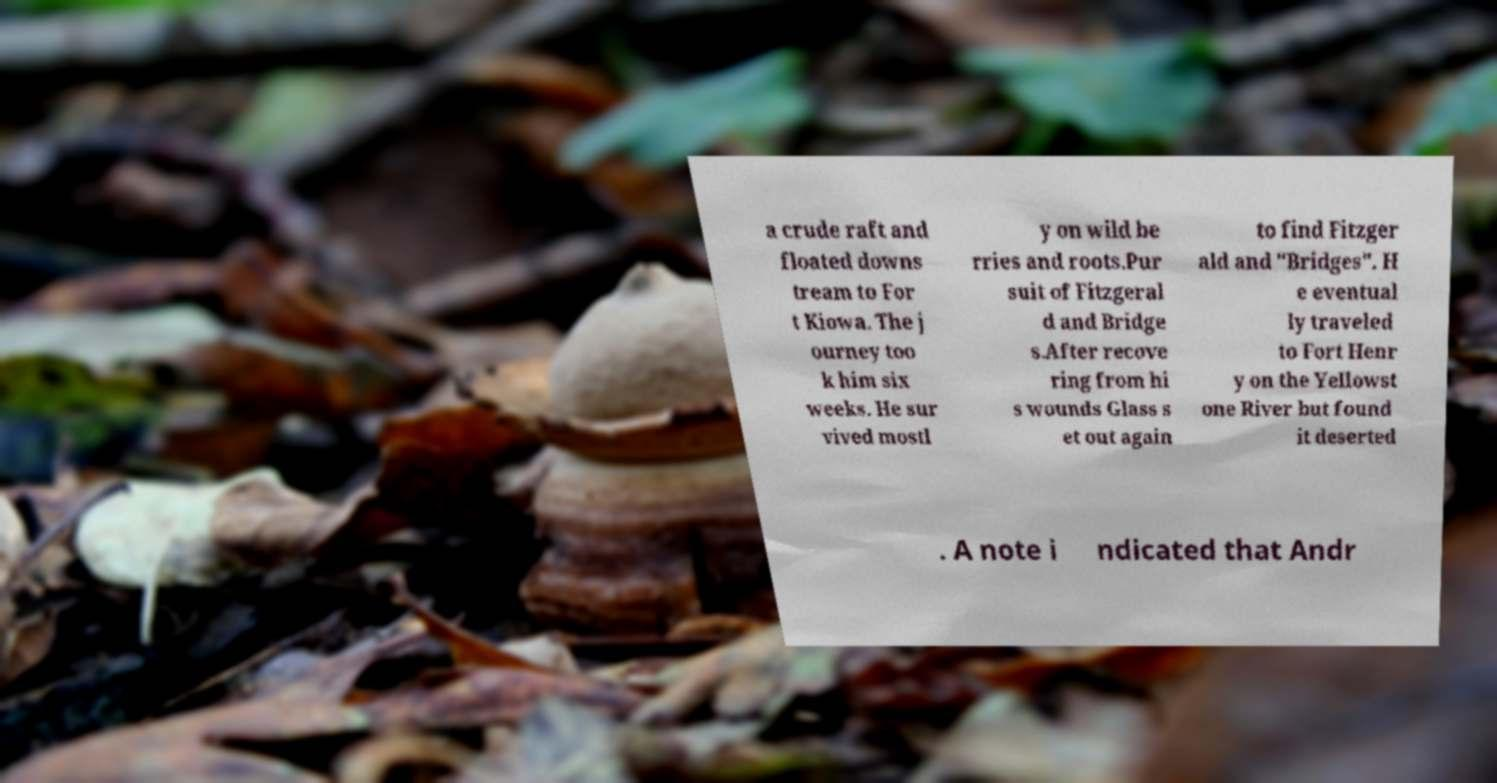Could you assist in decoding the text presented in this image and type it out clearly? a crude raft and floated downs tream to For t Kiowa. The j ourney too k him six weeks. He sur vived mostl y on wild be rries and roots.Pur suit of Fitzgeral d and Bridge s.After recove ring from hi s wounds Glass s et out again to find Fitzger ald and "Bridges". H e eventual ly traveled to Fort Henr y on the Yellowst one River but found it deserted . A note i ndicated that Andr 